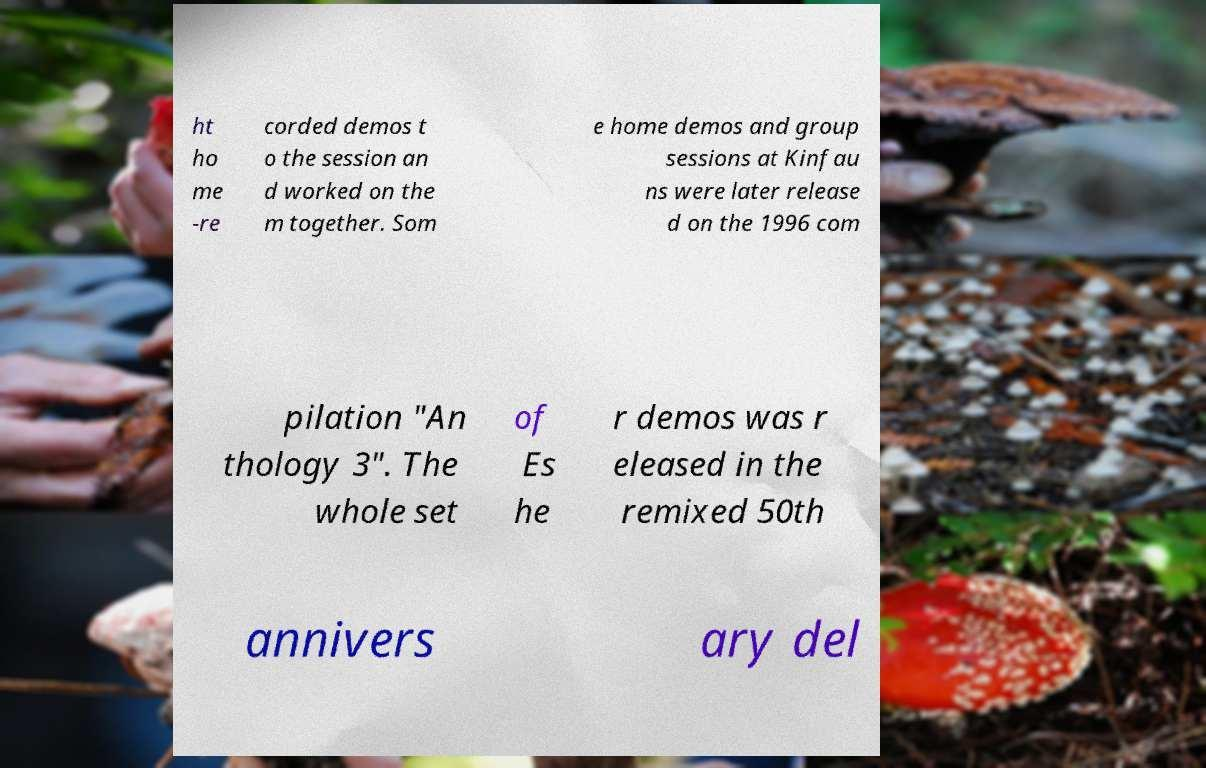Can you accurately transcribe the text from the provided image for me? ht ho me -re corded demos t o the session an d worked on the m together. Som e home demos and group sessions at Kinfau ns were later release d on the 1996 com pilation "An thology 3". The whole set of Es he r demos was r eleased in the remixed 50th annivers ary del 